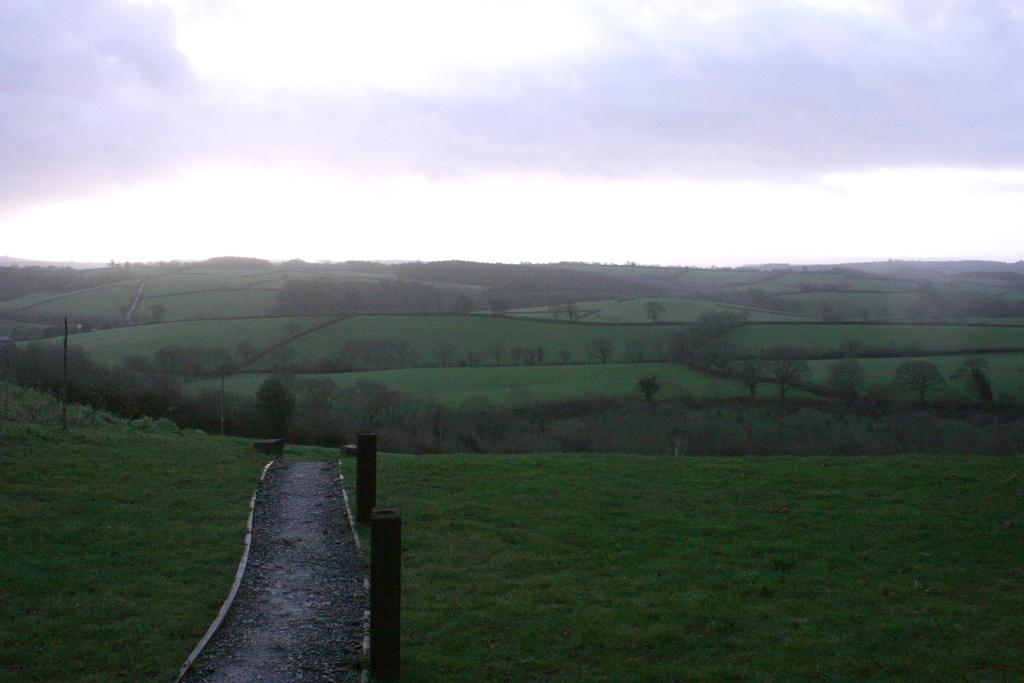What type of terrain is visible in the image? There is an open grass ground in the image. What natural elements can be seen in the image? There are trees and clouds visible in the image. What man-made structures are present in the image? There are poles in the image. What part of the natural environment is visible in the image? The sky is visible in the image. Can you see a clam digging in the grass ground in the image? There is no clam present in the image, and clams are not typically found in grassy areas. 